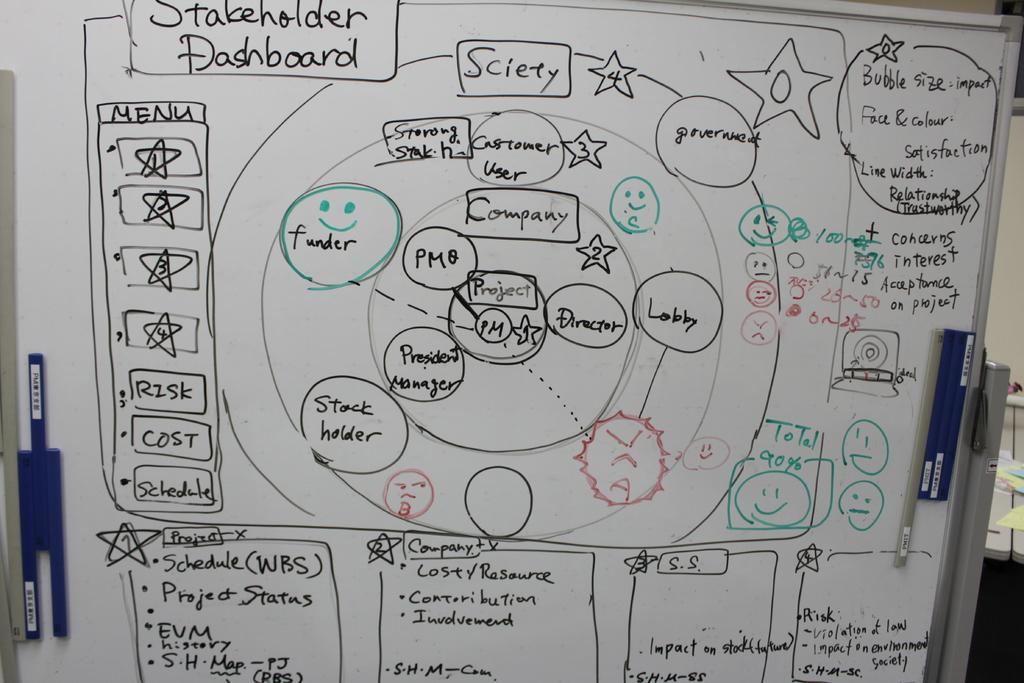What is being described in these notes?
Your answer should be very brief. Stakeholder dashboard. What is the title in the box at the top of the board?
Your response must be concise. Stakeholder dashboard. 